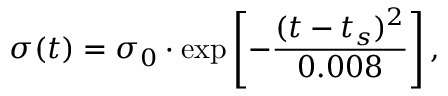<formula> <loc_0><loc_0><loc_500><loc_500>\sigma ( t ) = \sigma _ { 0 } \cdot \exp \left [ - \frac { ( t - t _ { s } ) ^ { 2 } } { 0 . 0 0 8 } \right ] ,</formula> 